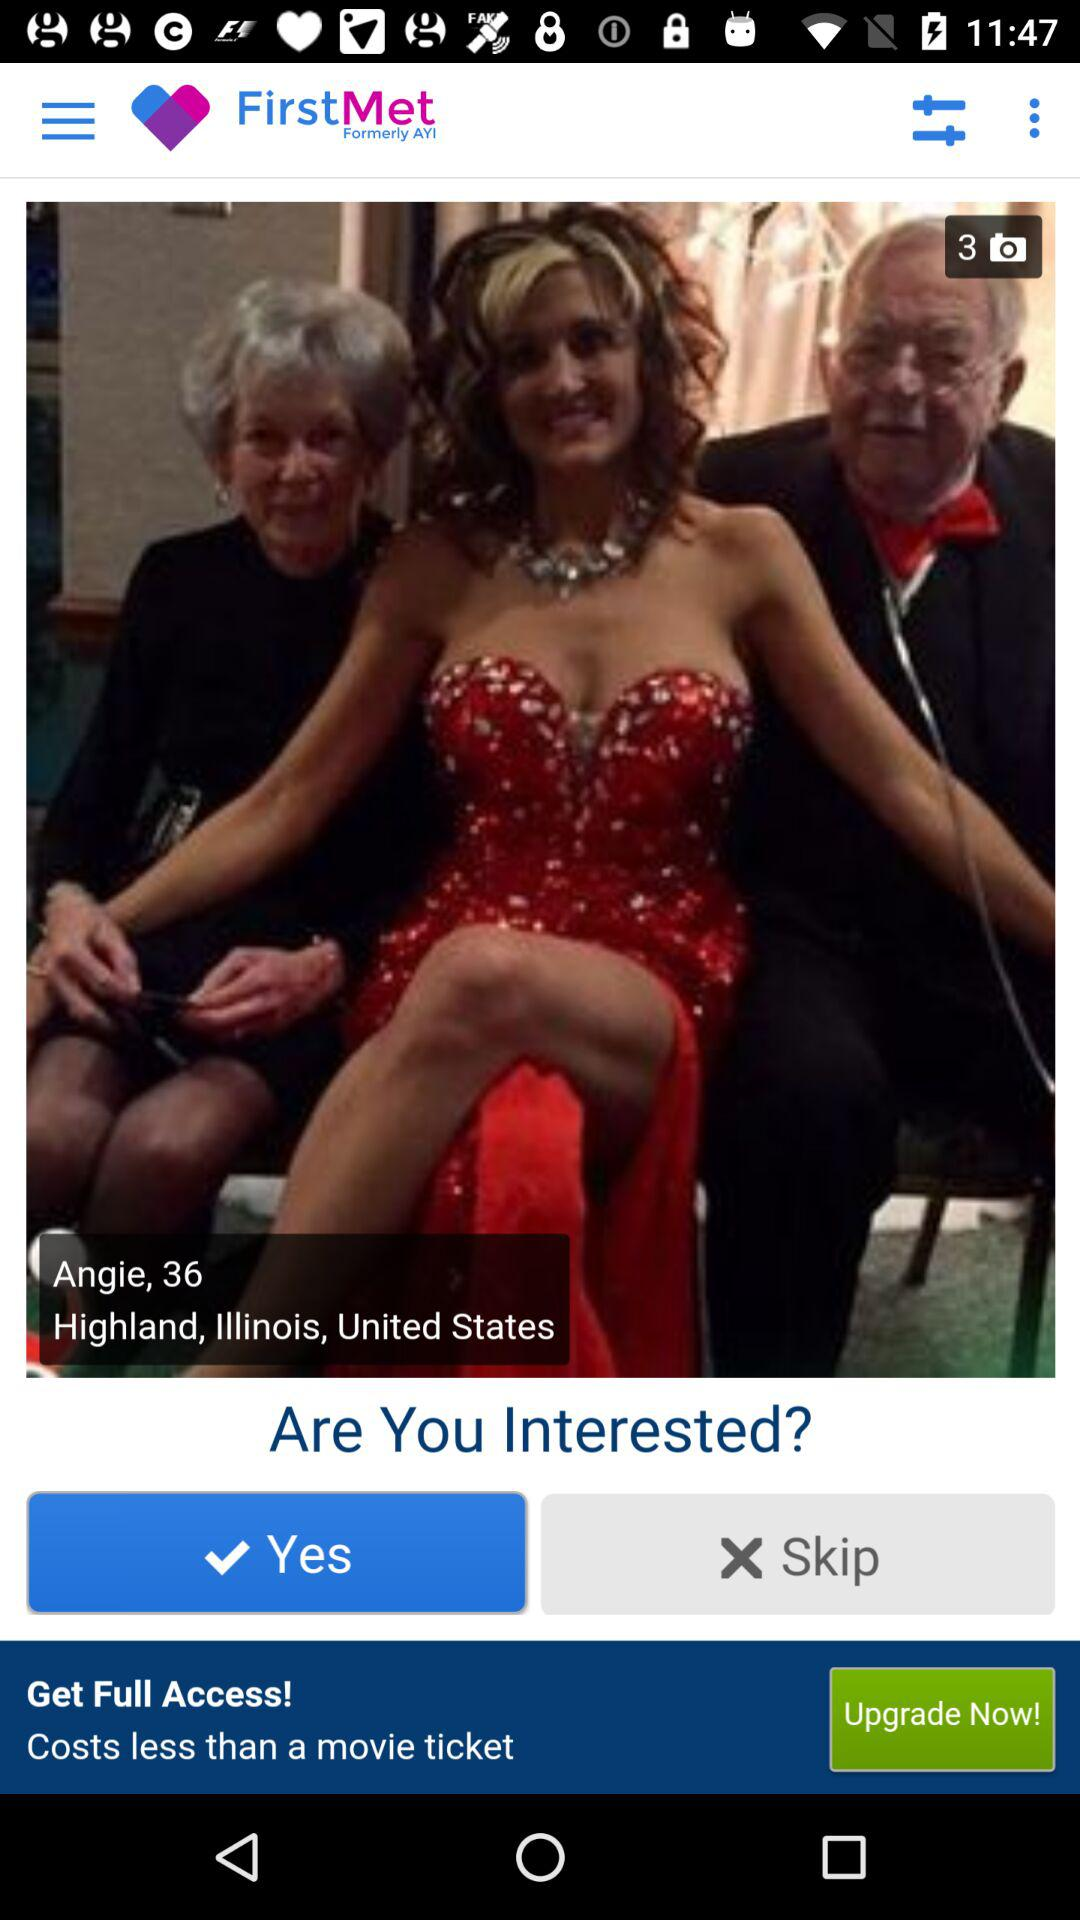What is the login name? The login name is Raphael. 